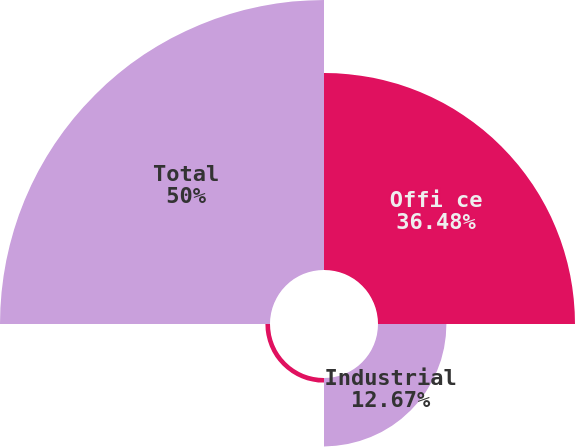Convert chart. <chart><loc_0><loc_0><loc_500><loc_500><pie_chart><fcel>Offi ce<fcel>Industrial<fcel>Non-Segment<fcel>Total<nl><fcel>36.48%<fcel>12.67%<fcel>0.85%<fcel>50.0%<nl></chart> 